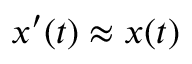<formula> <loc_0><loc_0><loc_500><loc_500>x ^ { \prime } ( t ) \approx x ( t )</formula> 